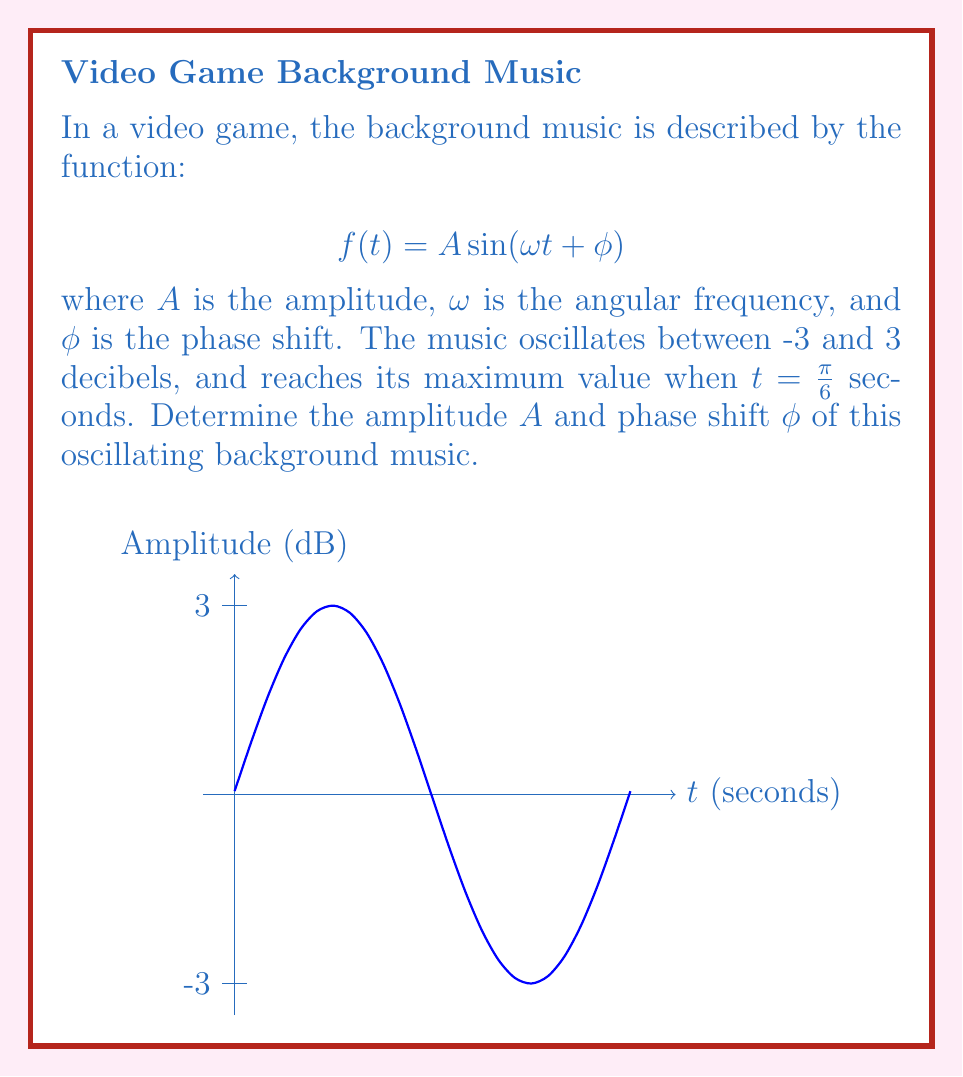Provide a solution to this math problem. Let's approach this step-by-step:

1) The amplitude $A$ is half the difference between the maximum and minimum values:
   $$A = \frac{3 - (-3)}{2} = 3$$ decibels

2) For the phase shift $\phi$, we know that the function reaches its maximum when $t = \frac{\pi}{6}$. At a maximum point:
   $$\omega t + \phi = \frac{\pi}{2} + 2\pi n$$ where $n$ is an integer

3) Substituting $t = \frac{\pi}{6}$:
   $$\omega \cdot \frac{\pi}{6} + \phi = \frac{\pi}{2}$$

4) We need to determine $\omega$. The period of $\sin$ is $2\pi$, so:
   $$\omega \cdot \frac{2\pi}{\omega} = 2\pi$$

5) Substituting this into the equation from step 3:
   $$\frac{\pi}{6} + \phi = \frac{\pi}{2}$$

6) Solving for $\phi$:
   $$\phi = \frac{\pi}{2} - \frac{\pi}{6} = \frac{\pi}{3}$$

Therefore, the amplitude $A$ is 3 decibels and the phase shift $\phi$ is $\frac{\pi}{3}$ radians.
Answer: $A = 3$ dB, $\phi = \frac{\pi}{3}$ rad 